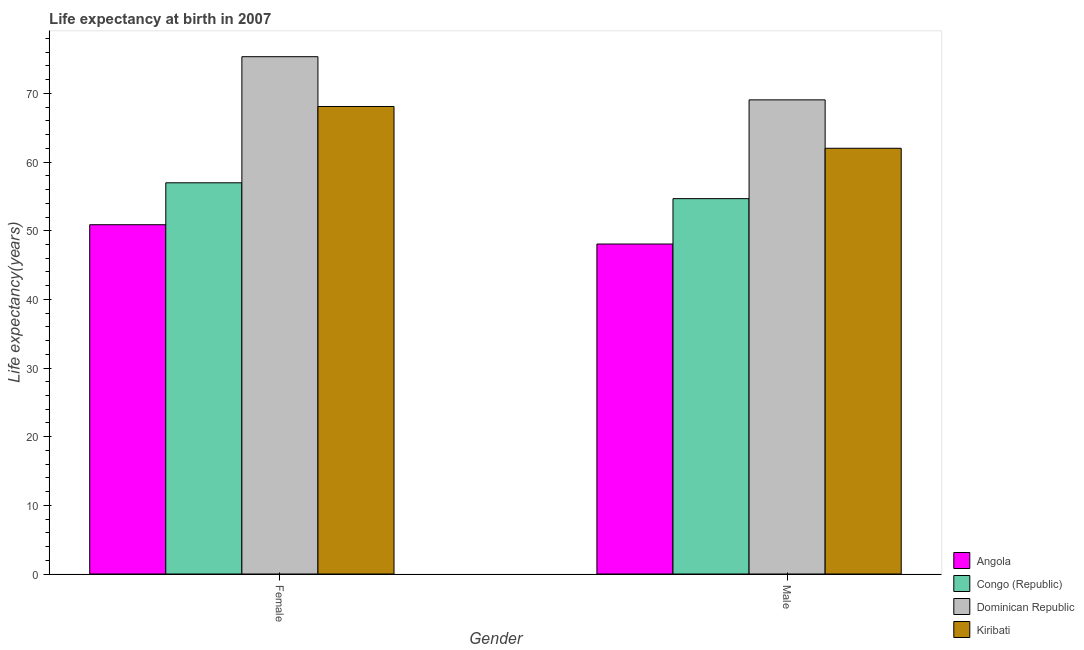How many bars are there on the 2nd tick from the right?
Provide a succinct answer. 4. What is the life expectancy(male) in Kiribati?
Offer a terse response. 62.01. Across all countries, what is the maximum life expectancy(male)?
Keep it short and to the point. 69.06. Across all countries, what is the minimum life expectancy(female)?
Offer a terse response. 50.88. In which country was the life expectancy(female) maximum?
Your answer should be compact. Dominican Republic. In which country was the life expectancy(female) minimum?
Make the answer very short. Angola. What is the total life expectancy(female) in the graph?
Make the answer very short. 251.31. What is the difference between the life expectancy(male) in Kiribati and that in Dominican Republic?
Keep it short and to the point. -7.05. What is the difference between the life expectancy(female) in Dominican Republic and the life expectancy(male) in Congo (Republic)?
Your answer should be very brief. 20.68. What is the average life expectancy(male) per country?
Offer a very short reply. 58.45. What is the difference between the life expectancy(male) and life expectancy(female) in Dominican Republic?
Keep it short and to the point. -6.29. What is the ratio of the life expectancy(male) in Congo (Republic) to that in Dominican Republic?
Provide a succinct answer. 0.79. Is the life expectancy(female) in Dominican Republic less than that in Angola?
Your answer should be very brief. No. What does the 2nd bar from the left in Female represents?
Ensure brevity in your answer.  Congo (Republic). What does the 2nd bar from the right in Female represents?
Give a very brief answer. Dominican Republic. How many bars are there?
Keep it short and to the point. 8. How many countries are there in the graph?
Your answer should be very brief. 4. Are the values on the major ticks of Y-axis written in scientific E-notation?
Provide a short and direct response. No. What is the title of the graph?
Give a very brief answer. Life expectancy at birth in 2007. What is the label or title of the X-axis?
Provide a succinct answer. Gender. What is the label or title of the Y-axis?
Give a very brief answer. Life expectancy(years). What is the Life expectancy(years) of Angola in Female?
Give a very brief answer. 50.88. What is the Life expectancy(years) in Congo (Republic) in Female?
Make the answer very short. 56.98. What is the Life expectancy(years) in Dominican Republic in Female?
Your response must be concise. 75.35. What is the Life expectancy(years) of Kiribati in Female?
Make the answer very short. 68.1. What is the Life expectancy(years) in Angola in Male?
Offer a terse response. 48.06. What is the Life expectancy(years) of Congo (Republic) in Male?
Make the answer very short. 54.67. What is the Life expectancy(years) in Dominican Republic in Male?
Offer a terse response. 69.06. What is the Life expectancy(years) of Kiribati in Male?
Make the answer very short. 62.01. Across all Gender, what is the maximum Life expectancy(years) in Angola?
Provide a short and direct response. 50.88. Across all Gender, what is the maximum Life expectancy(years) in Congo (Republic)?
Make the answer very short. 56.98. Across all Gender, what is the maximum Life expectancy(years) of Dominican Republic?
Keep it short and to the point. 75.35. Across all Gender, what is the maximum Life expectancy(years) of Kiribati?
Your response must be concise. 68.1. Across all Gender, what is the minimum Life expectancy(years) in Angola?
Your answer should be very brief. 48.06. Across all Gender, what is the minimum Life expectancy(years) of Congo (Republic)?
Keep it short and to the point. 54.67. Across all Gender, what is the minimum Life expectancy(years) in Dominican Republic?
Provide a succinct answer. 69.06. Across all Gender, what is the minimum Life expectancy(years) of Kiribati?
Your answer should be compact. 62.01. What is the total Life expectancy(years) of Angola in the graph?
Provide a short and direct response. 98.94. What is the total Life expectancy(years) of Congo (Republic) in the graph?
Your answer should be very brief. 111.66. What is the total Life expectancy(years) of Dominican Republic in the graph?
Offer a very short reply. 144.42. What is the total Life expectancy(years) of Kiribati in the graph?
Give a very brief answer. 130.11. What is the difference between the Life expectancy(years) in Angola in Female and that in Male?
Give a very brief answer. 2.81. What is the difference between the Life expectancy(years) in Congo (Republic) in Female and that in Male?
Ensure brevity in your answer.  2.31. What is the difference between the Life expectancy(years) of Dominican Republic in Female and that in Male?
Your answer should be compact. 6.29. What is the difference between the Life expectancy(years) of Kiribati in Female and that in Male?
Your answer should be compact. 6.09. What is the difference between the Life expectancy(years) in Angola in Female and the Life expectancy(years) in Congo (Republic) in Male?
Offer a very short reply. -3.8. What is the difference between the Life expectancy(years) of Angola in Female and the Life expectancy(years) of Dominican Republic in Male?
Make the answer very short. -18.19. What is the difference between the Life expectancy(years) of Angola in Female and the Life expectancy(years) of Kiribati in Male?
Ensure brevity in your answer.  -11.14. What is the difference between the Life expectancy(years) of Congo (Republic) in Female and the Life expectancy(years) of Dominican Republic in Male?
Your answer should be compact. -12.08. What is the difference between the Life expectancy(years) in Congo (Republic) in Female and the Life expectancy(years) in Kiribati in Male?
Offer a terse response. -5.03. What is the difference between the Life expectancy(years) of Dominican Republic in Female and the Life expectancy(years) of Kiribati in Male?
Your answer should be very brief. 13.34. What is the average Life expectancy(years) of Angola per Gender?
Offer a very short reply. 49.47. What is the average Life expectancy(years) of Congo (Republic) per Gender?
Your answer should be very brief. 55.83. What is the average Life expectancy(years) of Dominican Republic per Gender?
Offer a terse response. 72.21. What is the average Life expectancy(years) in Kiribati per Gender?
Give a very brief answer. 65.06. What is the difference between the Life expectancy(years) in Angola and Life expectancy(years) in Congo (Republic) in Female?
Offer a very short reply. -6.11. What is the difference between the Life expectancy(years) of Angola and Life expectancy(years) of Dominican Republic in Female?
Provide a succinct answer. -24.48. What is the difference between the Life expectancy(years) in Angola and Life expectancy(years) in Kiribati in Female?
Make the answer very short. -17.22. What is the difference between the Life expectancy(years) of Congo (Republic) and Life expectancy(years) of Dominican Republic in Female?
Give a very brief answer. -18.37. What is the difference between the Life expectancy(years) in Congo (Republic) and Life expectancy(years) in Kiribati in Female?
Give a very brief answer. -11.11. What is the difference between the Life expectancy(years) in Dominican Republic and Life expectancy(years) in Kiribati in Female?
Ensure brevity in your answer.  7.25. What is the difference between the Life expectancy(years) of Angola and Life expectancy(years) of Congo (Republic) in Male?
Offer a terse response. -6.61. What is the difference between the Life expectancy(years) of Angola and Life expectancy(years) of Dominican Republic in Male?
Ensure brevity in your answer.  -21. What is the difference between the Life expectancy(years) in Angola and Life expectancy(years) in Kiribati in Male?
Offer a very short reply. -13.95. What is the difference between the Life expectancy(years) of Congo (Republic) and Life expectancy(years) of Dominican Republic in Male?
Provide a succinct answer. -14.39. What is the difference between the Life expectancy(years) of Congo (Republic) and Life expectancy(years) of Kiribati in Male?
Your answer should be very brief. -7.34. What is the difference between the Life expectancy(years) of Dominican Republic and Life expectancy(years) of Kiribati in Male?
Your response must be concise. 7.05. What is the ratio of the Life expectancy(years) in Angola in Female to that in Male?
Offer a terse response. 1.06. What is the ratio of the Life expectancy(years) of Congo (Republic) in Female to that in Male?
Your response must be concise. 1.04. What is the ratio of the Life expectancy(years) in Dominican Republic in Female to that in Male?
Make the answer very short. 1.09. What is the ratio of the Life expectancy(years) of Kiribati in Female to that in Male?
Your response must be concise. 1.1. What is the difference between the highest and the second highest Life expectancy(years) in Angola?
Your answer should be very brief. 2.81. What is the difference between the highest and the second highest Life expectancy(years) of Congo (Republic)?
Provide a short and direct response. 2.31. What is the difference between the highest and the second highest Life expectancy(years) in Dominican Republic?
Make the answer very short. 6.29. What is the difference between the highest and the second highest Life expectancy(years) in Kiribati?
Your answer should be compact. 6.09. What is the difference between the highest and the lowest Life expectancy(years) in Angola?
Offer a terse response. 2.81. What is the difference between the highest and the lowest Life expectancy(years) of Congo (Republic)?
Give a very brief answer. 2.31. What is the difference between the highest and the lowest Life expectancy(years) of Dominican Republic?
Provide a short and direct response. 6.29. What is the difference between the highest and the lowest Life expectancy(years) of Kiribati?
Give a very brief answer. 6.09. 